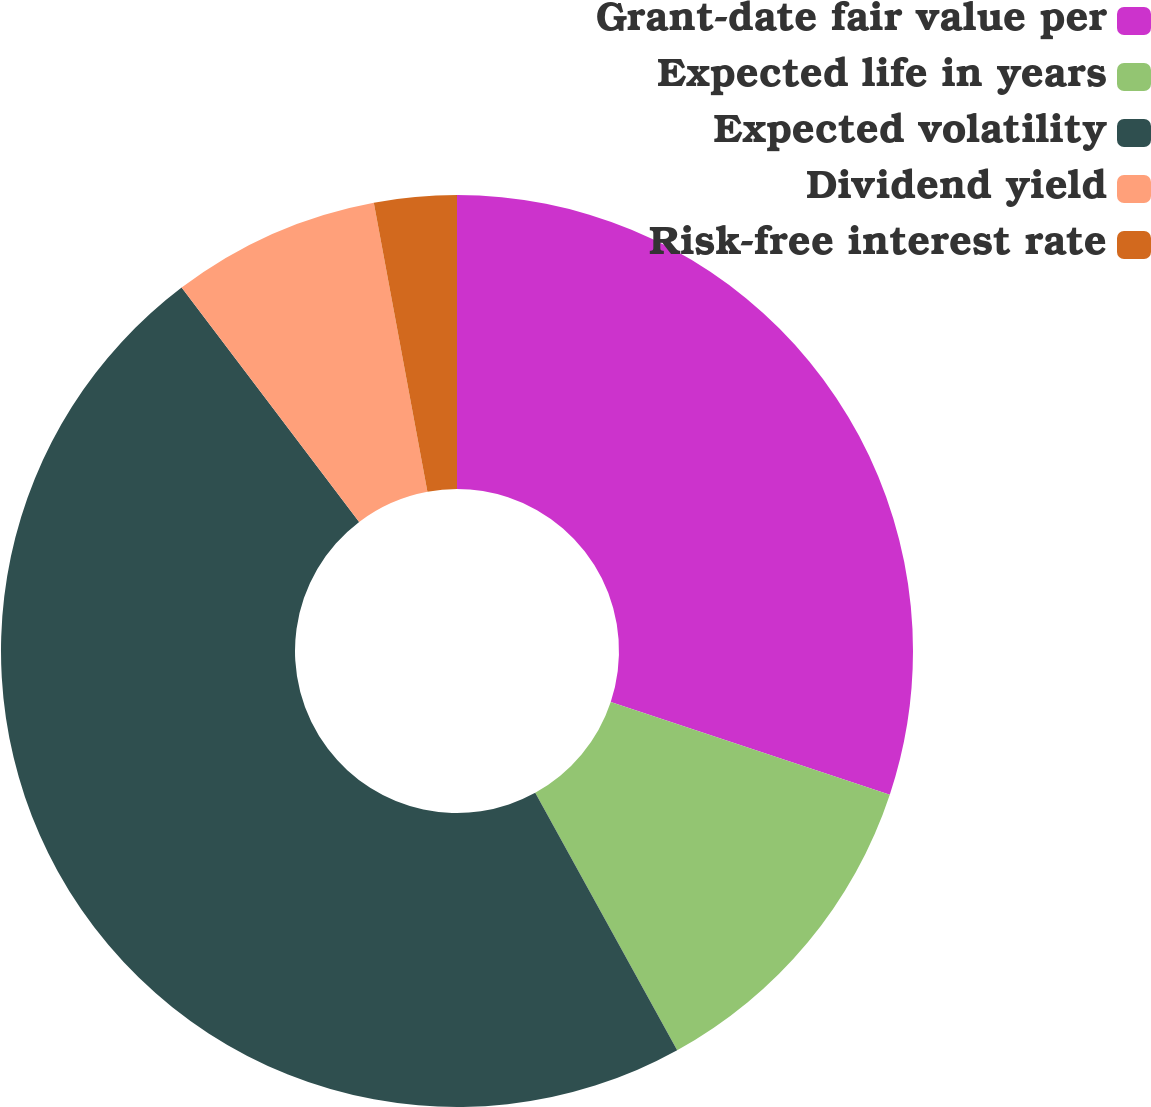Convert chart. <chart><loc_0><loc_0><loc_500><loc_500><pie_chart><fcel>Grant-date fair value per<fcel>Expected life in years<fcel>Expected volatility<fcel>Dividend yield<fcel>Risk-free interest rate<nl><fcel>30.1%<fcel>11.88%<fcel>47.7%<fcel>7.4%<fcel>2.92%<nl></chart> 